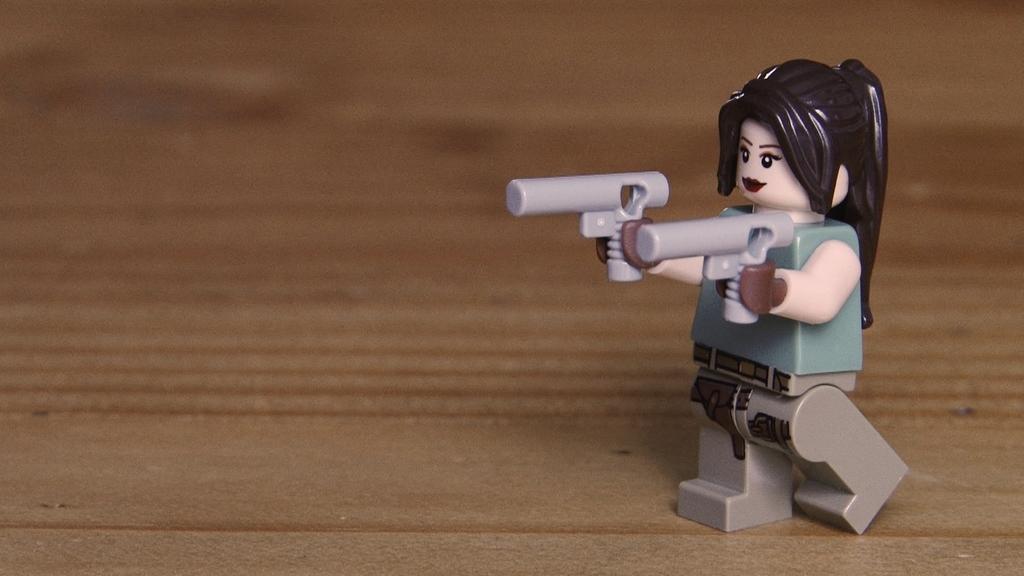Could you give a brief overview of what you see in this image? In this image I can see a toy on the right side. I can also see brown colour in the background. 